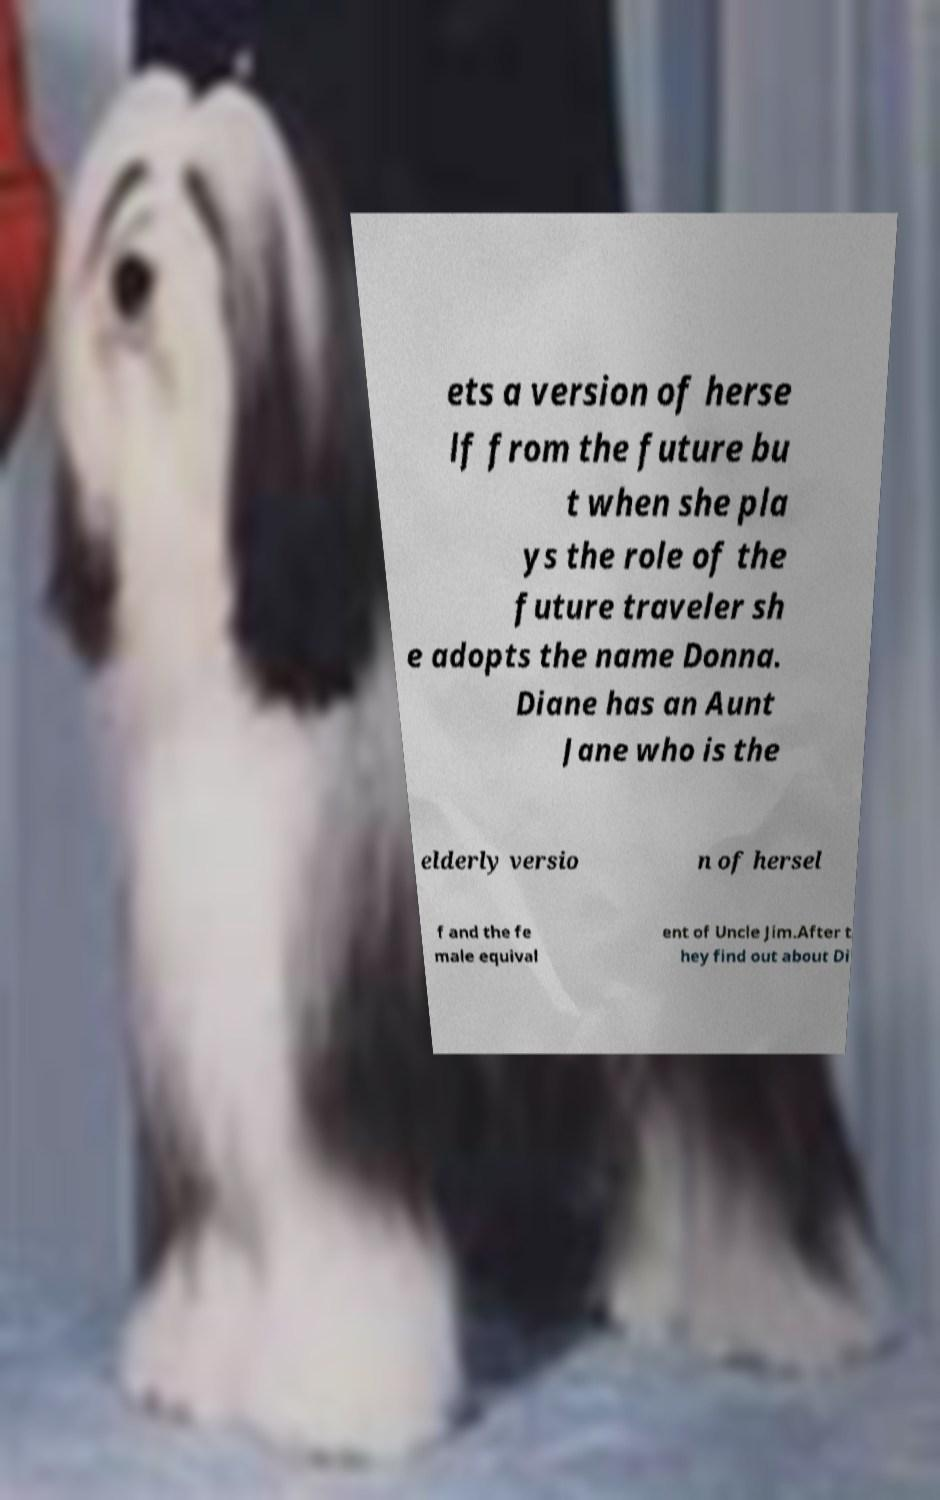Please identify and transcribe the text found in this image. ets a version of herse lf from the future bu t when she pla ys the role of the future traveler sh e adopts the name Donna. Diane has an Aunt Jane who is the elderly versio n of hersel f and the fe male equival ent of Uncle Jim.After t hey find out about Di 